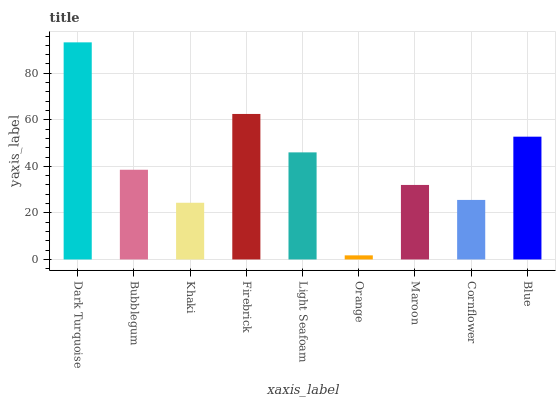Is Orange the minimum?
Answer yes or no. Yes. Is Dark Turquoise the maximum?
Answer yes or no. Yes. Is Bubblegum the minimum?
Answer yes or no. No. Is Bubblegum the maximum?
Answer yes or no. No. Is Dark Turquoise greater than Bubblegum?
Answer yes or no. Yes. Is Bubblegum less than Dark Turquoise?
Answer yes or no. Yes. Is Bubblegum greater than Dark Turquoise?
Answer yes or no. No. Is Dark Turquoise less than Bubblegum?
Answer yes or no. No. Is Bubblegum the high median?
Answer yes or no. Yes. Is Bubblegum the low median?
Answer yes or no. Yes. Is Blue the high median?
Answer yes or no. No. Is Khaki the low median?
Answer yes or no. No. 